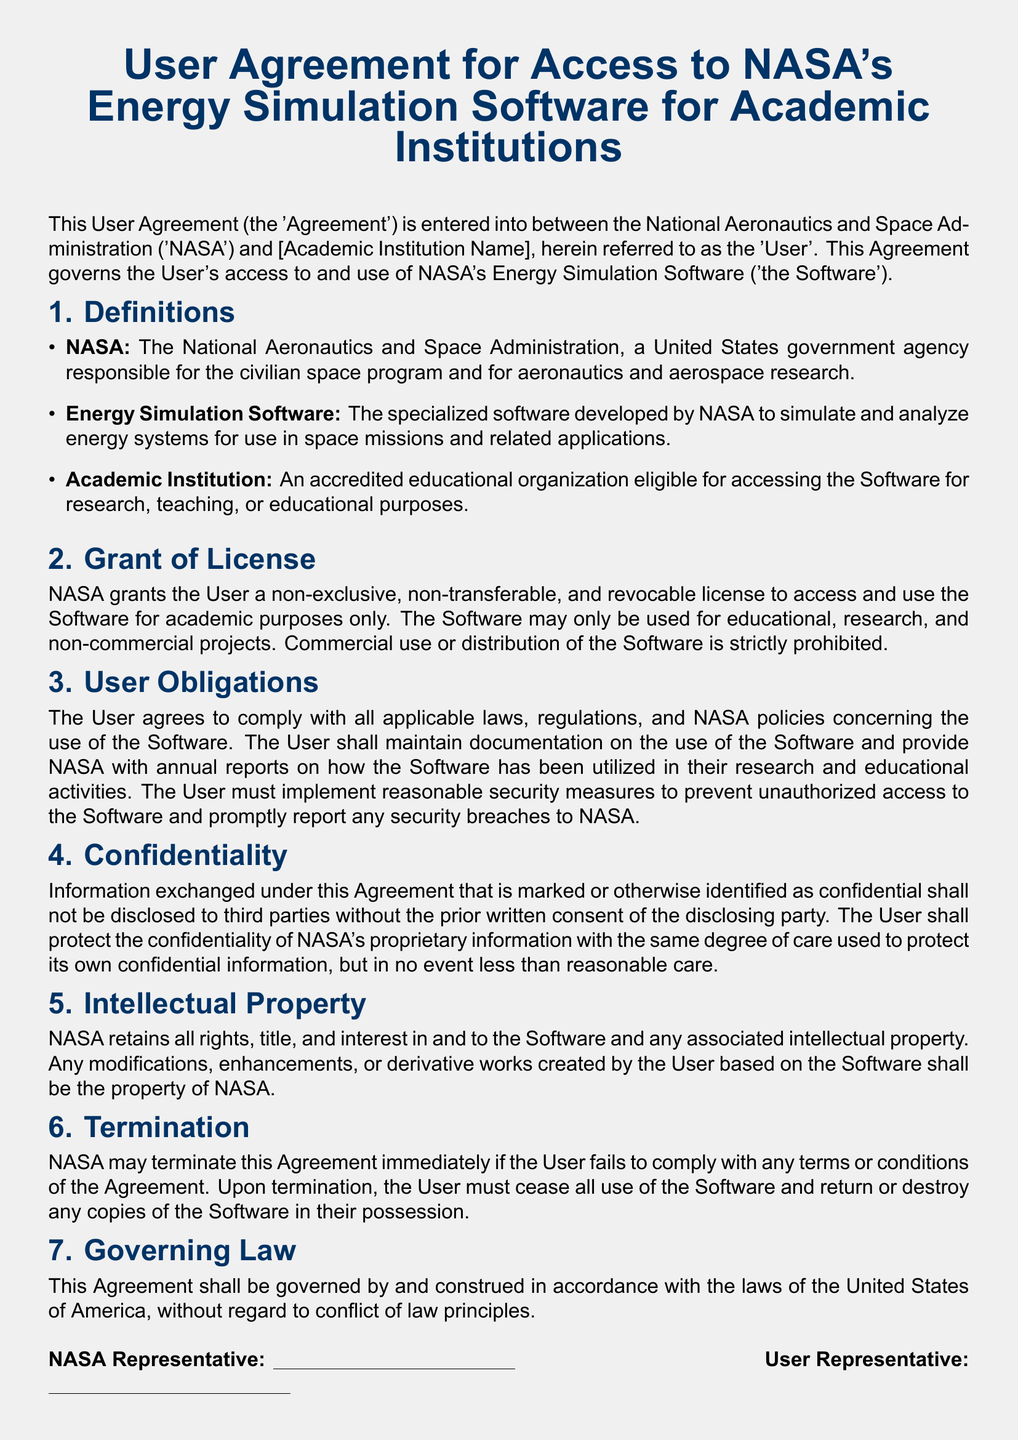What is the title of the document? The title of the document is presented at the beginning and summarizes its purpose.
Answer: User Agreement for Access to NASA's Energy Simulation Software for Academic Institutions Who is the User in the Agreement? The User is defined in the document as the party entering into the Agreement with NASA.
Answer: [Academic Institution Name] What type of license does NASA grant to the User? The type of license is specified in the Grant of License section of the document.
Answer: Non-exclusive, non-transferable, and revocable What is prohibited according to the Grant of License? Prohibited actions are listed in the Grant of License section concerning the use of the Software.
Answer: Commercial use or distribution What must the User maintain regarding the Software? This obligation is outlined in the User Obligations section regarding the use of the Software.
Answer: Documentation on the use of the Software What should the User do in case of a security breach? The document specifies actions the User must take regarding security breaches in the User Obligations section.
Answer: Promptly report any security breaches to NASA What degree of care must the User take to protect NASA's proprietary information? The confidentiality requirements detail the care the User must exercise to protect NASA's information.
Answer: Reasonable care What happens if the User fails to comply with the Agreement? The consequences of non-compliance are described in the Termination section of the document.
Answer: NASA may terminate this Agreement immediately Under which law is the Agreement governed? The governing law is mentioned in the Governing Law section of the document.
Answer: Laws of the United States of America 